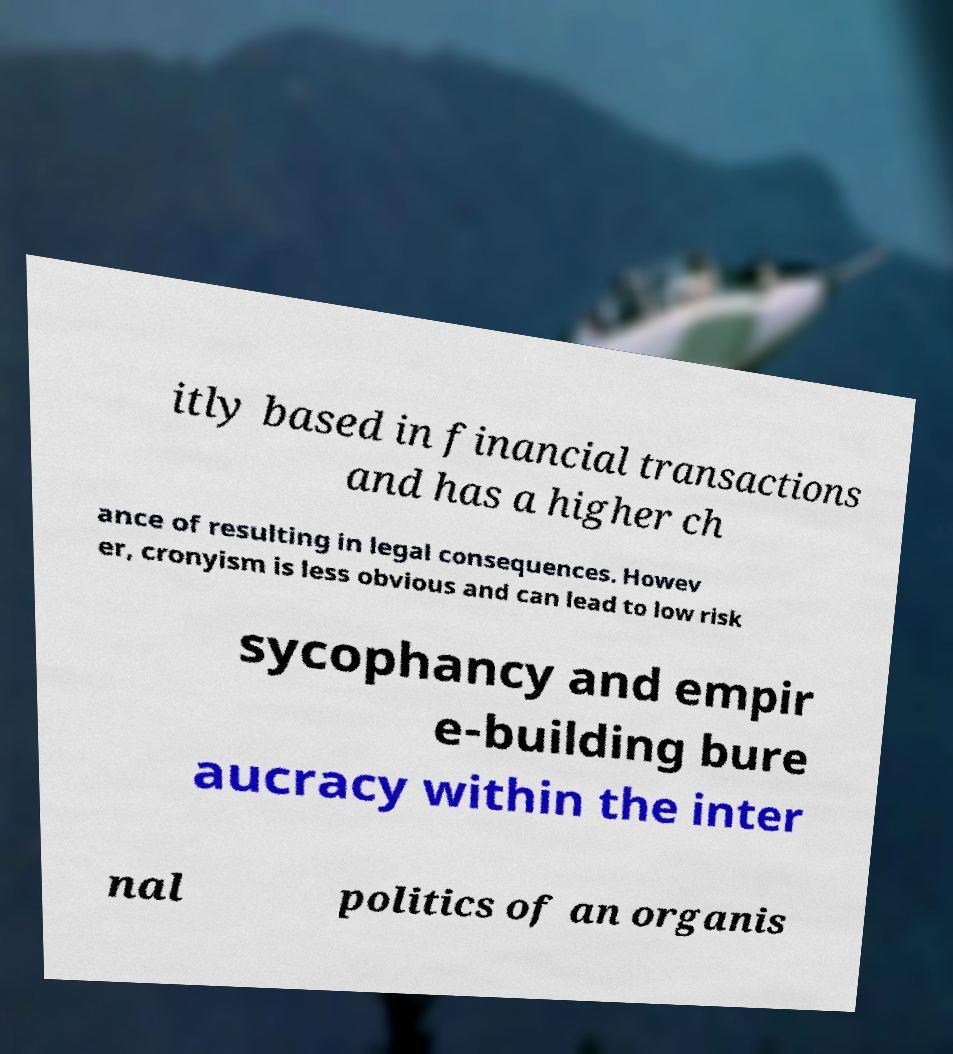Could you assist in decoding the text presented in this image and type it out clearly? itly based in financial transactions and has a higher ch ance of resulting in legal consequences. Howev er, cronyism is less obvious and can lead to low risk sycophancy and empir e-building bure aucracy within the inter nal politics of an organis 